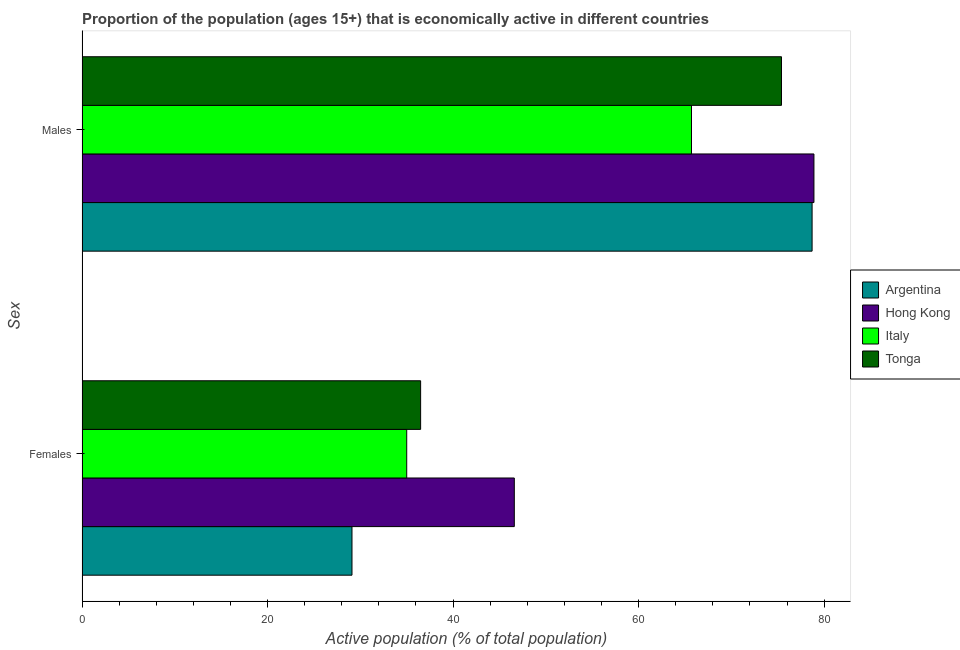How many groups of bars are there?
Ensure brevity in your answer.  2. Are the number of bars per tick equal to the number of legend labels?
Your answer should be very brief. Yes. Are the number of bars on each tick of the Y-axis equal?
Offer a very short reply. Yes. How many bars are there on the 1st tick from the top?
Provide a succinct answer. 4. What is the label of the 1st group of bars from the top?
Your answer should be compact. Males. What is the percentage of economically active male population in Italy?
Offer a terse response. 65.7. Across all countries, what is the maximum percentage of economically active female population?
Make the answer very short. 46.6. Across all countries, what is the minimum percentage of economically active male population?
Provide a succinct answer. 65.7. In which country was the percentage of economically active male population maximum?
Provide a short and direct response. Hong Kong. What is the total percentage of economically active female population in the graph?
Give a very brief answer. 147.2. What is the difference between the percentage of economically active female population in Italy and that in Hong Kong?
Keep it short and to the point. -11.6. What is the difference between the percentage of economically active male population in Hong Kong and the percentage of economically active female population in Argentina?
Offer a very short reply. 49.8. What is the average percentage of economically active male population per country?
Ensure brevity in your answer.  74.67. What is the difference between the percentage of economically active female population and percentage of economically active male population in Argentina?
Provide a succinct answer. -49.6. What is the ratio of the percentage of economically active female population in Argentina to that in Hong Kong?
Your answer should be compact. 0.62. Is the percentage of economically active male population in Italy less than that in Tonga?
Make the answer very short. Yes. In how many countries, is the percentage of economically active male population greater than the average percentage of economically active male population taken over all countries?
Ensure brevity in your answer.  3. How many countries are there in the graph?
Give a very brief answer. 4. Are the values on the major ticks of X-axis written in scientific E-notation?
Offer a terse response. No. Does the graph contain any zero values?
Give a very brief answer. No. Does the graph contain grids?
Ensure brevity in your answer.  No. What is the title of the graph?
Your response must be concise. Proportion of the population (ages 15+) that is economically active in different countries. Does "Zimbabwe" appear as one of the legend labels in the graph?
Offer a terse response. No. What is the label or title of the X-axis?
Your answer should be compact. Active population (% of total population). What is the label or title of the Y-axis?
Your response must be concise. Sex. What is the Active population (% of total population) in Argentina in Females?
Make the answer very short. 29.1. What is the Active population (% of total population) of Hong Kong in Females?
Provide a succinct answer. 46.6. What is the Active population (% of total population) in Italy in Females?
Your answer should be very brief. 35. What is the Active population (% of total population) in Tonga in Females?
Offer a very short reply. 36.5. What is the Active population (% of total population) in Argentina in Males?
Provide a short and direct response. 78.7. What is the Active population (% of total population) of Hong Kong in Males?
Your answer should be compact. 78.9. What is the Active population (% of total population) of Italy in Males?
Your answer should be very brief. 65.7. What is the Active population (% of total population) of Tonga in Males?
Provide a short and direct response. 75.4. Across all Sex, what is the maximum Active population (% of total population) of Argentina?
Your answer should be compact. 78.7. Across all Sex, what is the maximum Active population (% of total population) of Hong Kong?
Your response must be concise. 78.9. Across all Sex, what is the maximum Active population (% of total population) in Italy?
Provide a short and direct response. 65.7. Across all Sex, what is the maximum Active population (% of total population) in Tonga?
Offer a terse response. 75.4. Across all Sex, what is the minimum Active population (% of total population) of Argentina?
Ensure brevity in your answer.  29.1. Across all Sex, what is the minimum Active population (% of total population) in Hong Kong?
Make the answer very short. 46.6. Across all Sex, what is the minimum Active population (% of total population) of Italy?
Your response must be concise. 35. Across all Sex, what is the minimum Active population (% of total population) in Tonga?
Your response must be concise. 36.5. What is the total Active population (% of total population) in Argentina in the graph?
Give a very brief answer. 107.8. What is the total Active population (% of total population) of Hong Kong in the graph?
Ensure brevity in your answer.  125.5. What is the total Active population (% of total population) of Italy in the graph?
Offer a terse response. 100.7. What is the total Active population (% of total population) of Tonga in the graph?
Make the answer very short. 111.9. What is the difference between the Active population (% of total population) of Argentina in Females and that in Males?
Make the answer very short. -49.6. What is the difference between the Active population (% of total population) of Hong Kong in Females and that in Males?
Offer a very short reply. -32.3. What is the difference between the Active population (% of total population) of Italy in Females and that in Males?
Your answer should be compact. -30.7. What is the difference between the Active population (% of total population) in Tonga in Females and that in Males?
Your response must be concise. -38.9. What is the difference between the Active population (% of total population) of Argentina in Females and the Active population (% of total population) of Hong Kong in Males?
Offer a terse response. -49.8. What is the difference between the Active population (% of total population) in Argentina in Females and the Active population (% of total population) in Italy in Males?
Offer a terse response. -36.6. What is the difference between the Active population (% of total population) in Argentina in Females and the Active population (% of total population) in Tonga in Males?
Make the answer very short. -46.3. What is the difference between the Active population (% of total population) of Hong Kong in Females and the Active population (% of total population) of Italy in Males?
Provide a short and direct response. -19.1. What is the difference between the Active population (% of total population) in Hong Kong in Females and the Active population (% of total population) in Tonga in Males?
Give a very brief answer. -28.8. What is the difference between the Active population (% of total population) of Italy in Females and the Active population (% of total population) of Tonga in Males?
Give a very brief answer. -40.4. What is the average Active population (% of total population) of Argentina per Sex?
Give a very brief answer. 53.9. What is the average Active population (% of total population) of Hong Kong per Sex?
Your response must be concise. 62.75. What is the average Active population (% of total population) in Italy per Sex?
Keep it short and to the point. 50.35. What is the average Active population (% of total population) of Tonga per Sex?
Make the answer very short. 55.95. What is the difference between the Active population (% of total population) of Argentina and Active population (% of total population) of Hong Kong in Females?
Ensure brevity in your answer.  -17.5. What is the difference between the Active population (% of total population) in Argentina and Active population (% of total population) in Tonga in Females?
Your answer should be very brief. -7.4. What is the difference between the Active population (% of total population) in Hong Kong and Active population (% of total population) in Italy in Females?
Your answer should be very brief. 11.6. What is the difference between the Active population (% of total population) in Argentina and Active population (% of total population) in Italy in Males?
Provide a succinct answer. 13. What is the difference between the Active population (% of total population) of Hong Kong and Active population (% of total population) of Tonga in Males?
Provide a succinct answer. 3.5. What is the ratio of the Active population (% of total population) in Argentina in Females to that in Males?
Provide a short and direct response. 0.37. What is the ratio of the Active population (% of total population) in Hong Kong in Females to that in Males?
Offer a very short reply. 0.59. What is the ratio of the Active population (% of total population) of Italy in Females to that in Males?
Your response must be concise. 0.53. What is the ratio of the Active population (% of total population) in Tonga in Females to that in Males?
Offer a very short reply. 0.48. What is the difference between the highest and the second highest Active population (% of total population) of Argentina?
Provide a succinct answer. 49.6. What is the difference between the highest and the second highest Active population (% of total population) in Hong Kong?
Give a very brief answer. 32.3. What is the difference between the highest and the second highest Active population (% of total population) of Italy?
Your response must be concise. 30.7. What is the difference between the highest and the second highest Active population (% of total population) of Tonga?
Provide a succinct answer. 38.9. What is the difference between the highest and the lowest Active population (% of total population) in Argentina?
Your response must be concise. 49.6. What is the difference between the highest and the lowest Active population (% of total population) of Hong Kong?
Ensure brevity in your answer.  32.3. What is the difference between the highest and the lowest Active population (% of total population) of Italy?
Your answer should be very brief. 30.7. What is the difference between the highest and the lowest Active population (% of total population) of Tonga?
Ensure brevity in your answer.  38.9. 